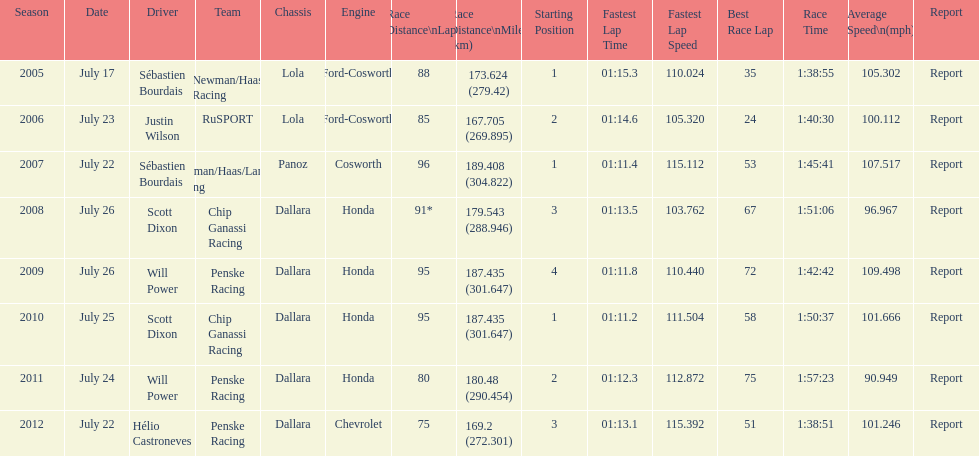Which team won the champ car world series the year before rusport? Newman/Haas Racing. 